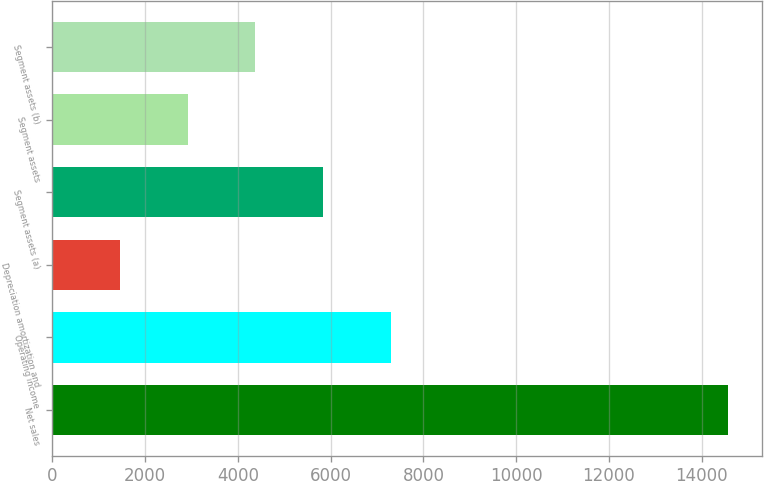<chart> <loc_0><loc_0><loc_500><loc_500><bar_chart><fcel>Net sales<fcel>Operating income<fcel>Depreciation amortization and<fcel>Segment assets (a)<fcel>Segment assets<fcel>Segment assets (b)<nl><fcel>14573<fcel>7291<fcel>1465.4<fcel>5834.6<fcel>2921.8<fcel>4378.2<nl></chart> 